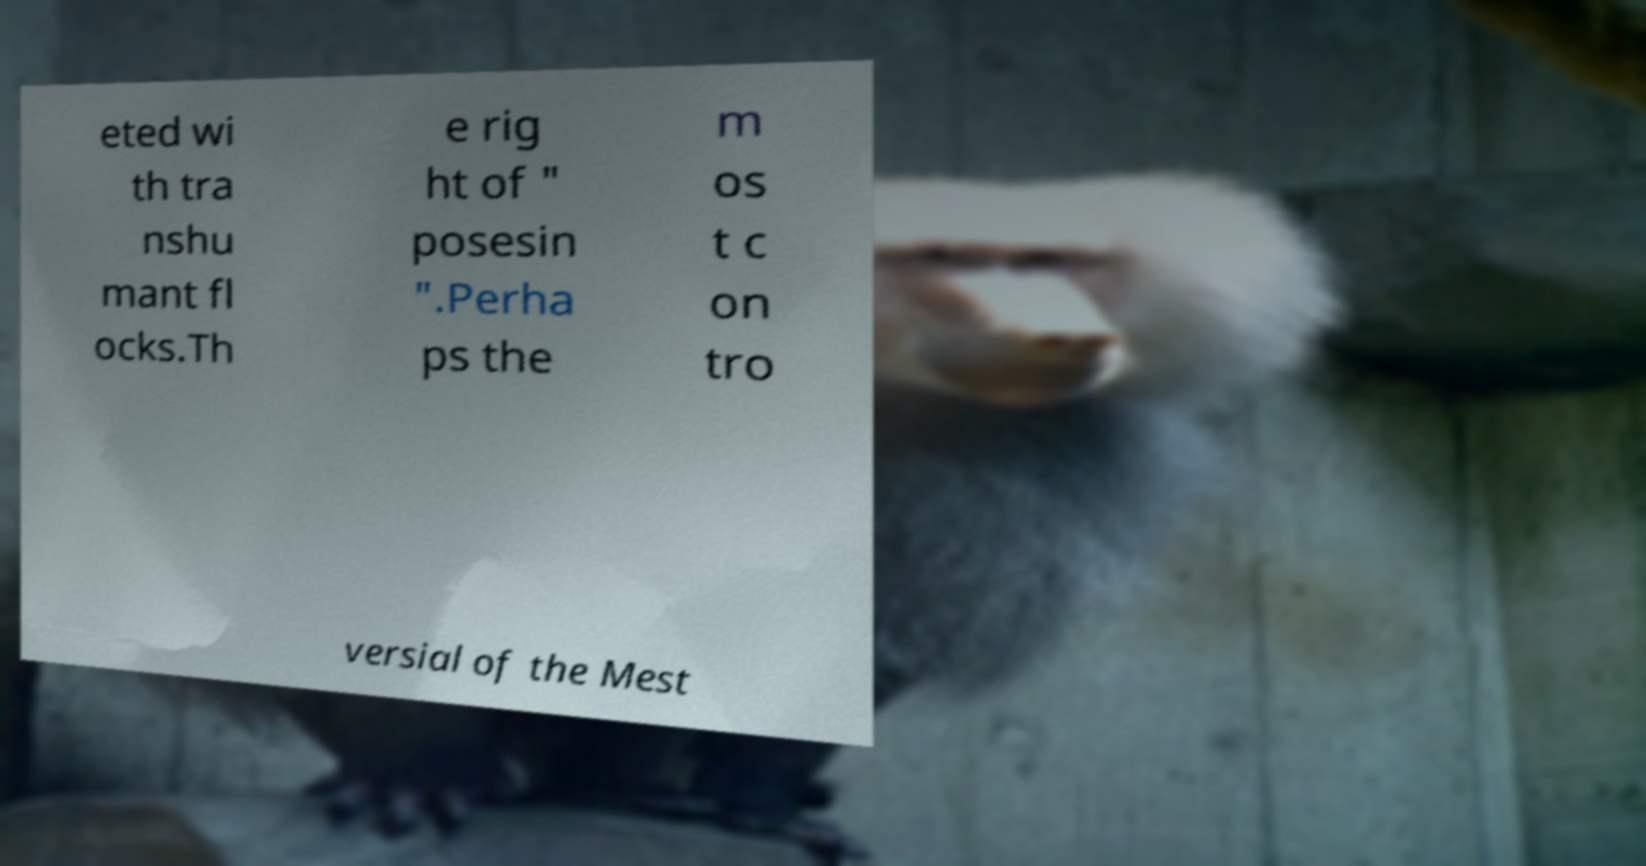Can you read and provide the text displayed in the image?This photo seems to have some interesting text. Can you extract and type it out for me? eted wi th tra nshu mant fl ocks.Th e rig ht of " posesin ".Perha ps the m os t c on tro versial of the Mest 